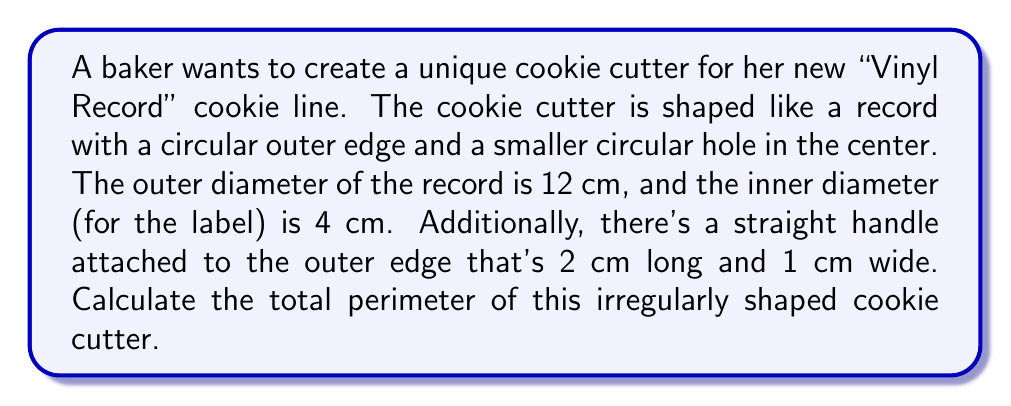Give your solution to this math problem. Let's break this down step-by-step:

1) First, we need to calculate the circumference of the outer circle:
   $$C_{outer} = \pi d_{outer} = \pi \cdot 12 = 12\pi \text{ cm}$$

2) Next, we calculate the circumference of the inner circle:
   $$C_{inner} = \pi d_{inner} = \pi \cdot 4 = 4\pi \text{ cm}$$

3) Now, we need to account for the handle. The handle adds two segments to the perimeter:
   - Where it attaches to the circle (1 cm)
   - The outer edge of the handle (2 cm)

4) However, we need to subtract the arc length of the outer circle that the handle replaces:
   Arc length = $\frac{1}{12\pi} \cdot 12\pi = 1 \text{ cm}$

5) So, the total perimeter is:
   $$P = C_{outer} + C_{inner} + 1 + 2 - 1$$
   $$P = 12\pi + 4\pi + 2 = 16\pi + 2 \text{ cm}$$

[asy]
import geometry;

size(200);
draw(circle((0,0),6), linewidth(1));
draw(circle((0,0),2), linewidth(1));
draw((6,0)--(8,0)--(8,0.5)--(6,0.5)--cycle, linewidth(1));
label("12 cm", (0,0), S);
label("4 cm", (0,0), N);
label("2 cm", (7,0.7), N);
label("1 cm", (6.5,-0.7), S);
[/asy]
Answer: $16\pi + 2$ cm 